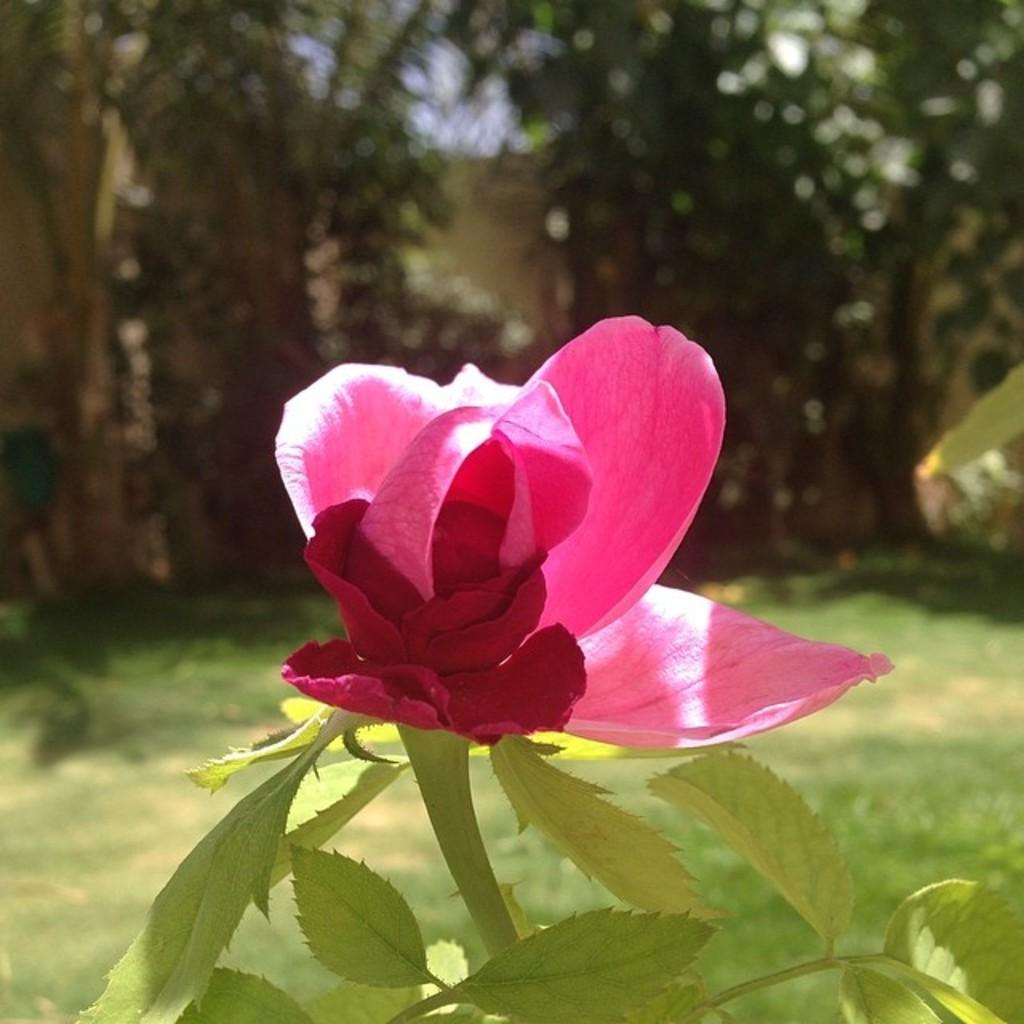What can be seen in the foreground of the picture? There are leaves and a rose flower in the foreground of the picture. What is visible in the background of the picture? There are trees and grass in the background of the picture. How would you describe the background of the picture? The background is not clear. What type of exchange is taking place between the leaves and the beast in the image? There is no beast present in the image, so there is no exchange taking place between the leaves and a beast. 